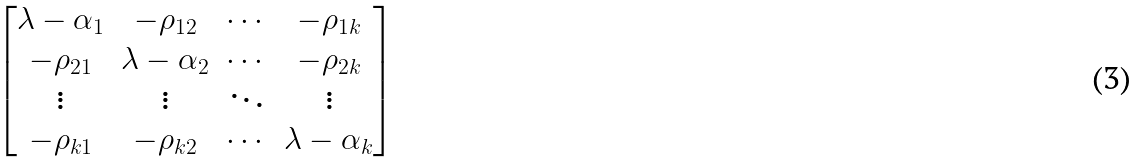Convert formula to latex. <formula><loc_0><loc_0><loc_500><loc_500>\begin{bmatrix} \lambda - \alpha _ { 1 } & - \rho _ { 1 2 } & \cdots & - \rho _ { 1 k } \\ - \rho _ { 2 1 } & \lambda - \alpha _ { 2 } & \cdots & - \rho _ { 2 k } \\ \vdots & \vdots & \ddots & \vdots \\ - \rho _ { k 1 } & - \rho _ { k 2 } & \cdots & \lambda - \alpha _ { k } \end{bmatrix}</formula> 